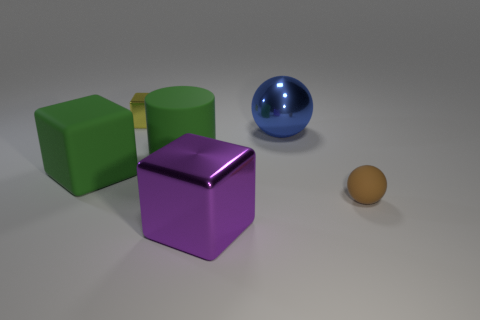Add 2 cyan cylinders. How many objects exist? 8 Subtract all shiny cubes. How many cubes are left? 1 Subtract all green cubes. How many cubes are left? 2 Subtract all small cubes. Subtract all green blocks. How many objects are left? 4 Add 4 metal spheres. How many metal spheres are left? 5 Add 4 tiny brown rubber objects. How many tiny brown rubber objects exist? 5 Subtract 0 yellow spheres. How many objects are left? 6 Subtract all cylinders. How many objects are left? 5 Subtract 1 cylinders. How many cylinders are left? 0 Subtract all cyan balls. Subtract all green cylinders. How many balls are left? 2 